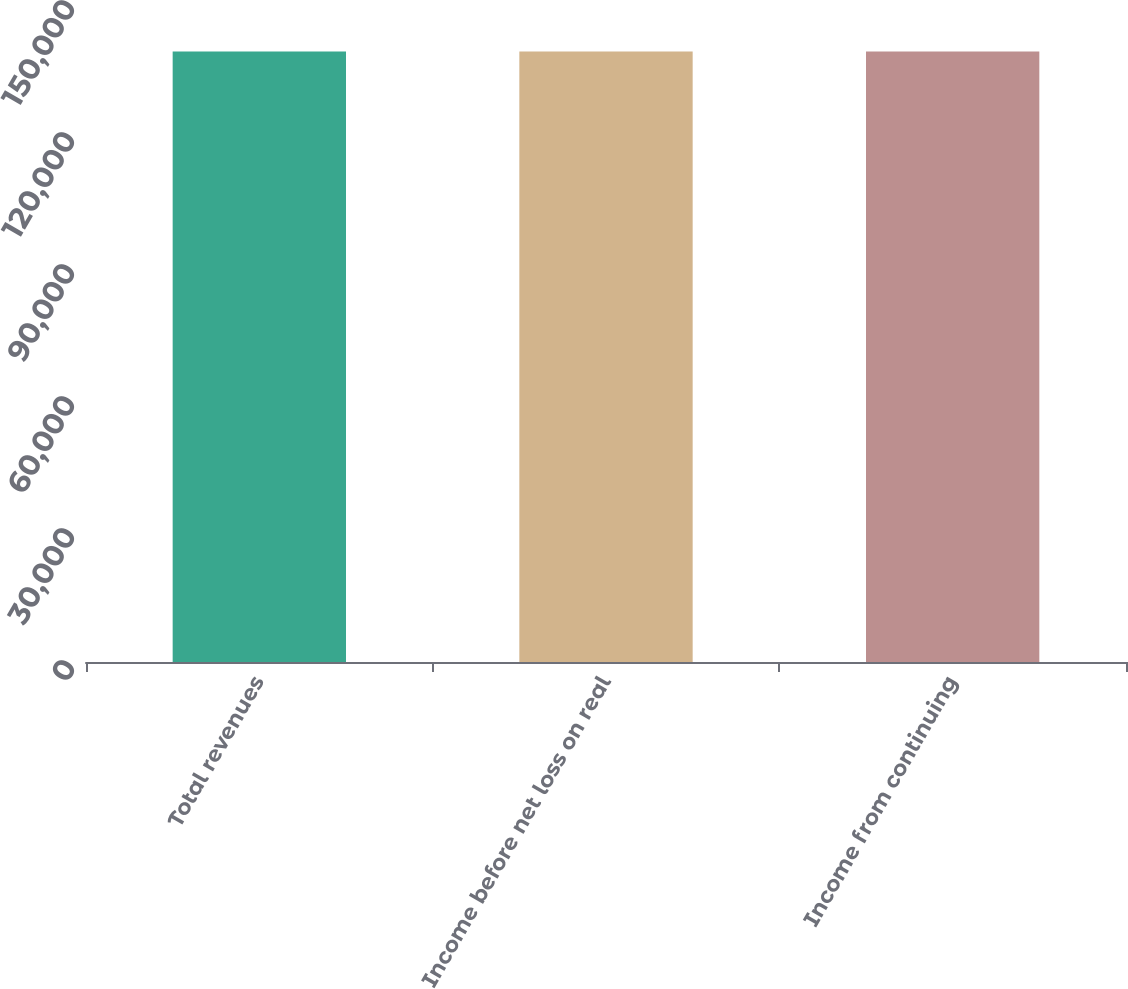<chart> <loc_0><loc_0><loc_500><loc_500><bar_chart><fcel>Total revenues<fcel>Income before net loss on real<fcel>Income from continuing<nl><fcel>138761<fcel>138761<fcel>138761<nl></chart> 